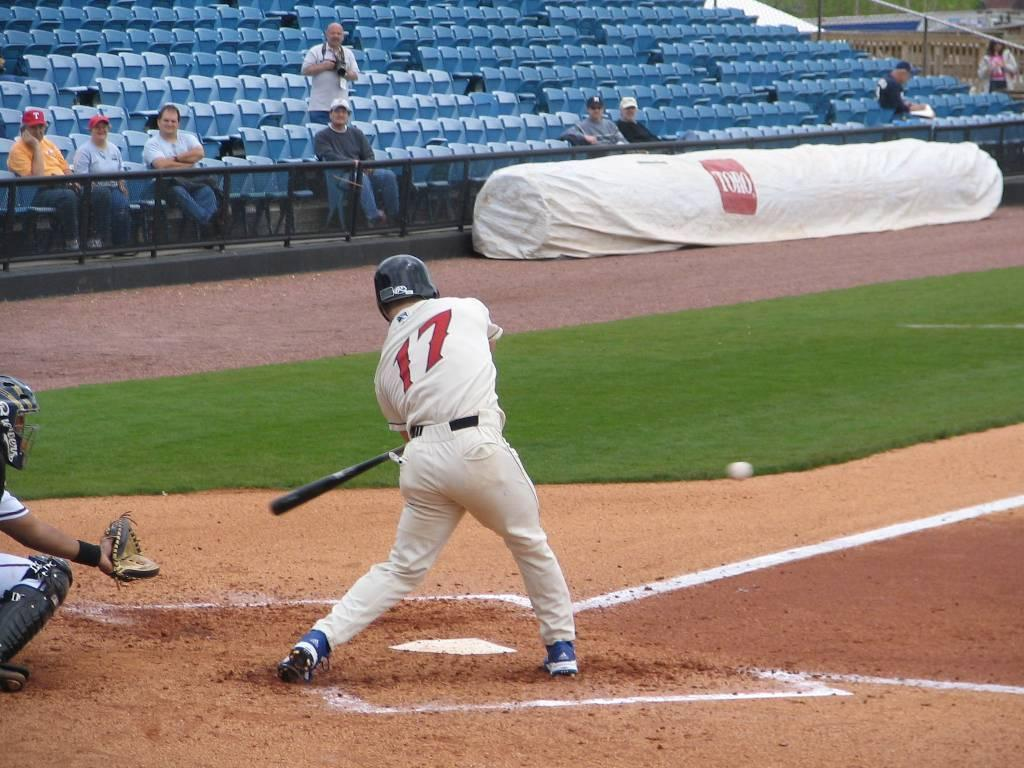<image>
Provide a brief description of the given image. Baseball player wearing the number 17 hitting the ball. 